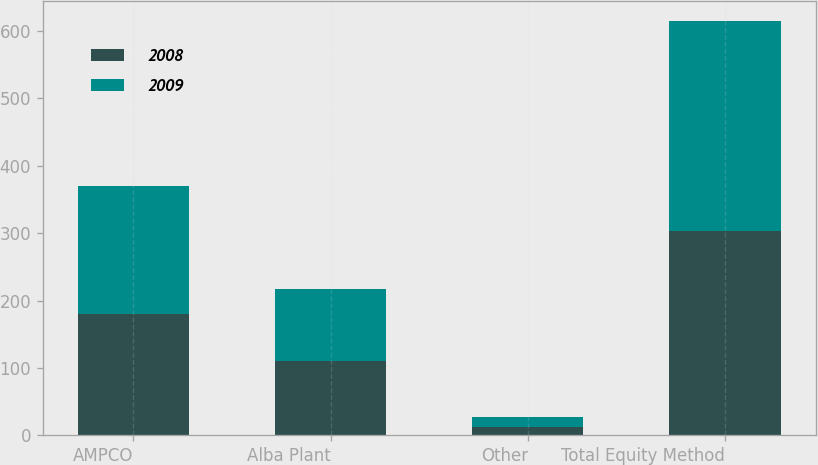Convert chart. <chart><loc_0><loc_0><loc_500><loc_500><stacked_bar_chart><ecel><fcel>AMPCO<fcel>Alba Plant<fcel>Other<fcel>Total Equity Method<nl><fcel>2008<fcel>180<fcel>111<fcel>12<fcel>303<nl><fcel>2009<fcel>190<fcel>106<fcel>15<fcel>311<nl></chart> 